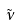Convert formula to latex. <formula><loc_0><loc_0><loc_500><loc_500>\tilde { \nu }</formula> 